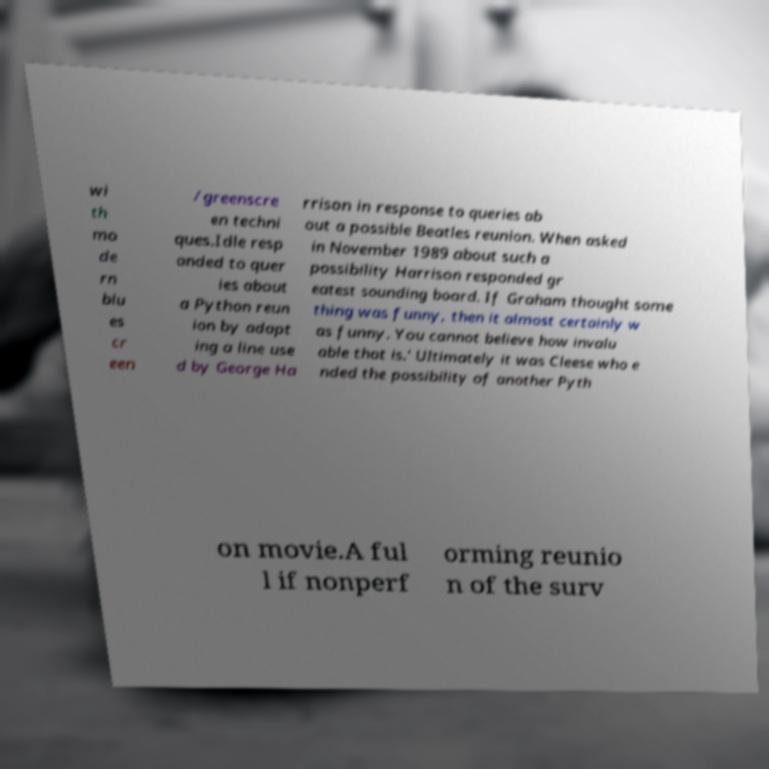Please read and relay the text visible in this image. What does it say? wi th mo de rn blu es cr een /greenscre en techni ques.Idle resp onded to quer ies about a Python reun ion by adapt ing a line use d by George Ha rrison in response to queries ab out a possible Beatles reunion. When asked in November 1989 about such a possibility Harrison responded gr eatest sounding board. If Graham thought some thing was funny, then it almost certainly w as funny. You cannot believe how invalu able that is.' Ultimately it was Cleese who e nded the possibility of another Pyth on movie.A ful l if nonperf orming reunio n of the surv 